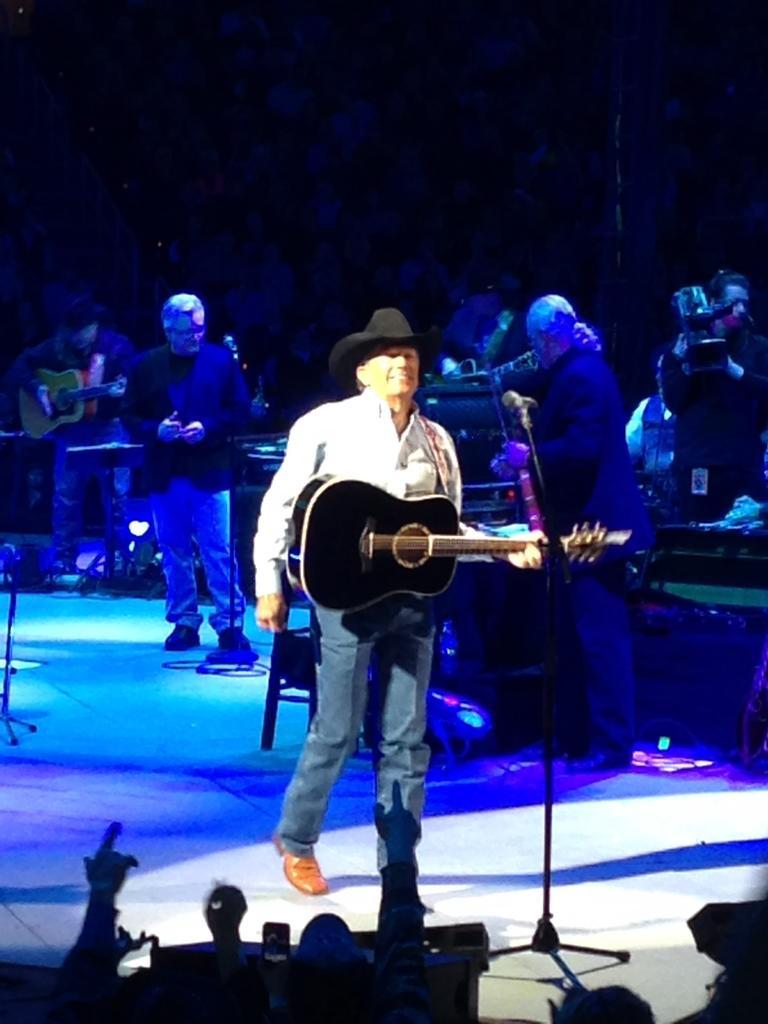In one or two sentences, can you explain what this image depicts? In this image I can see few people are standing and few of them are holding guitars. I can also see few mics in front of them. In the background I can see a man is holding a camera. 